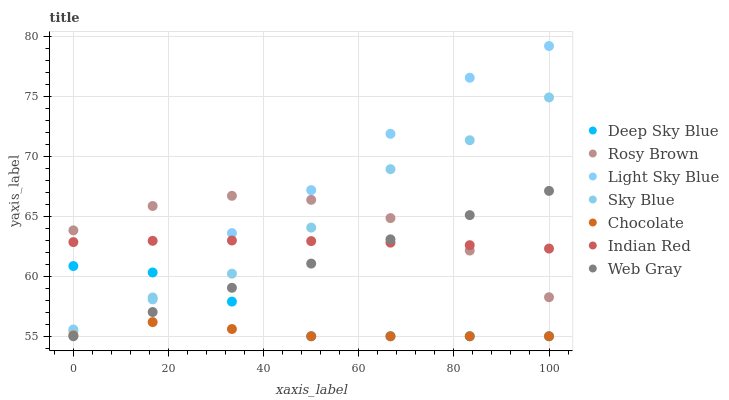Does Chocolate have the minimum area under the curve?
Answer yes or no. Yes. Does Light Sky Blue have the maximum area under the curve?
Answer yes or no. Yes. Does Deep Sky Blue have the minimum area under the curve?
Answer yes or no. No. Does Deep Sky Blue have the maximum area under the curve?
Answer yes or no. No. Is Web Gray the smoothest?
Answer yes or no. Yes. Is Light Sky Blue the roughest?
Answer yes or no. Yes. Is Deep Sky Blue the smoothest?
Answer yes or no. No. Is Deep Sky Blue the roughest?
Answer yes or no. No. Does Web Gray have the lowest value?
Answer yes or no. Yes. Does Rosy Brown have the lowest value?
Answer yes or no. No. Does Light Sky Blue have the highest value?
Answer yes or no. Yes. Does Deep Sky Blue have the highest value?
Answer yes or no. No. Is Web Gray less than Sky Blue?
Answer yes or no. Yes. Is Sky Blue greater than Web Gray?
Answer yes or no. Yes. Does Light Sky Blue intersect Sky Blue?
Answer yes or no. Yes. Is Light Sky Blue less than Sky Blue?
Answer yes or no. No. Is Light Sky Blue greater than Sky Blue?
Answer yes or no. No. Does Web Gray intersect Sky Blue?
Answer yes or no. No. 